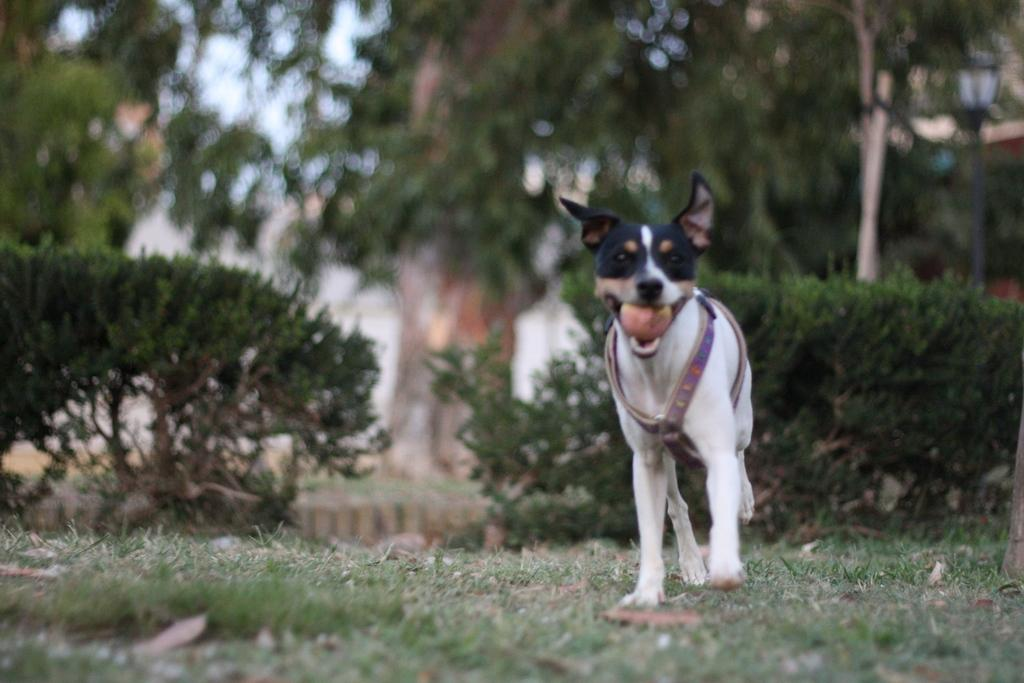What type of animal is present in the image? There is a dog in the image. What can be seen in the background of the image? There are green color trees in the image. What type of hen can be seen near the seashore in the image? There is no hen or seashore present in the image; it features a dog and green color trees. 